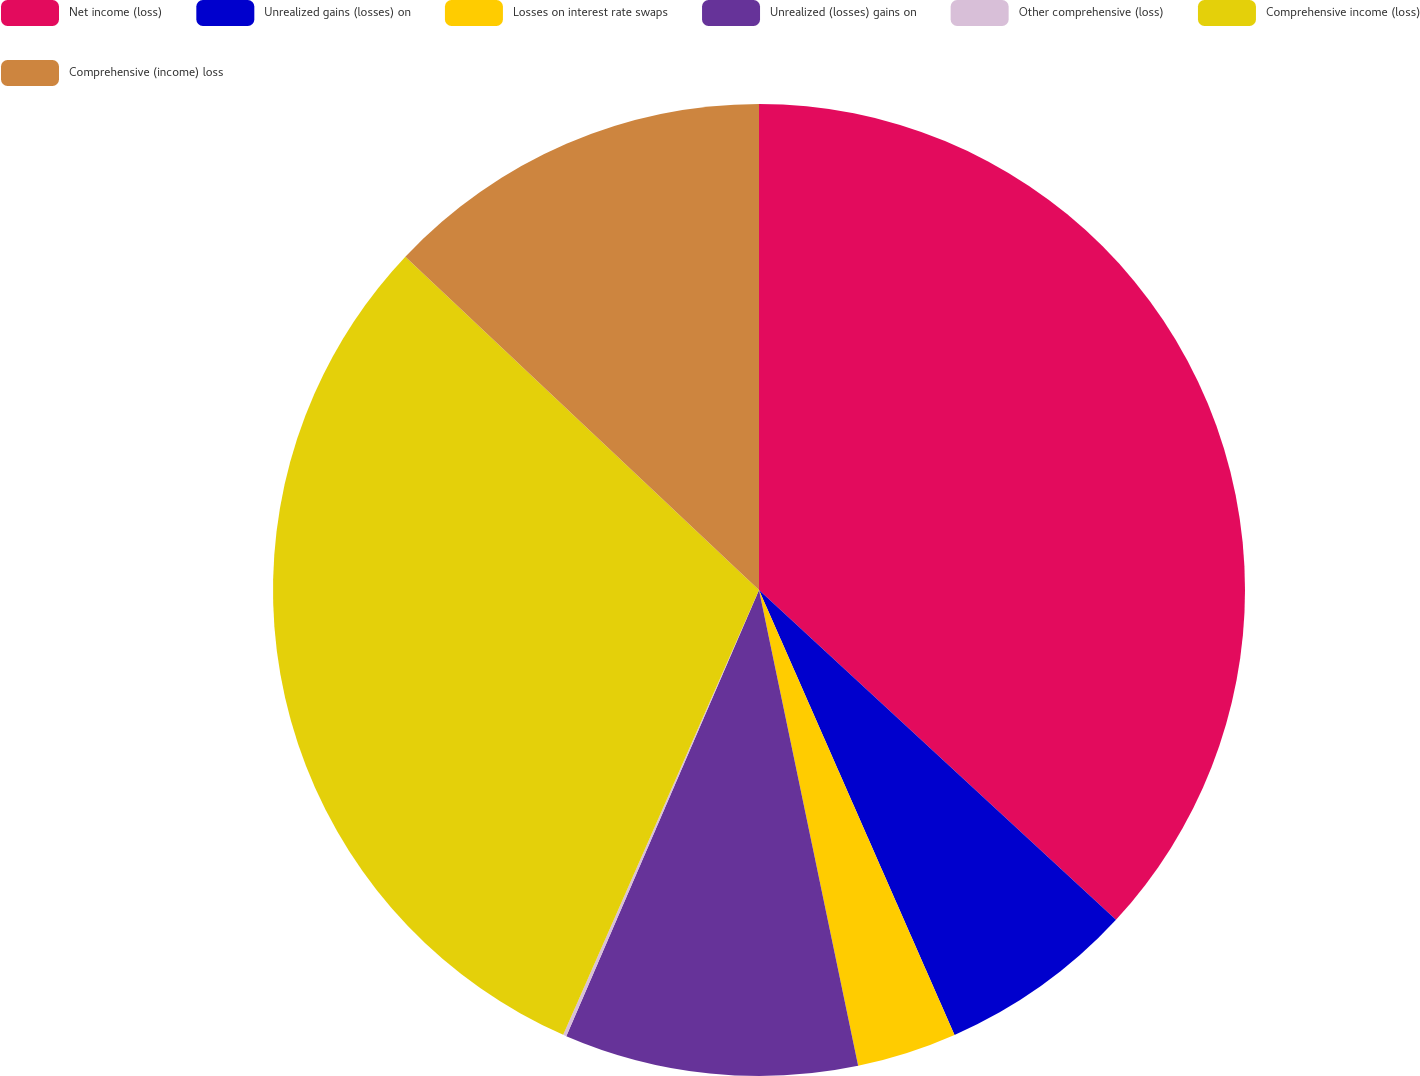<chart> <loc_0><loc_0><loc_500><loc_500><pie_chart><fcel>Net income (loss)<fcel>Unrealized gains (losses) on<fcel>Losses on interest rate swaps<fcel>Unrealized (losses) gains on<fcel>Other comprehensive (loss)<fcel>Comprehensive income (loss)<fcel>Comprehensive (income) loss<nl><fcel>36.87%<fcel>6.54%<fcel>3.32%<fcel>9.76%<fcel>0.11%<fcel>30.43%<fcel>12.97%<nl></chart> 